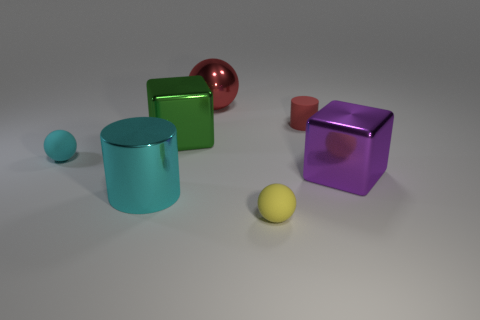Subtract all yellow matte balls. How many balls are left? 2 Add 1 metal cylinders. How many objects exist? 8 Subtract all purple blocks. How many blocks are left? 1 Subtract 1 cubes. How many cubes are left? 1 Subtract all spheres. How many objects are left? 4 Subtract all large cyan matte balls. Subtract all cyan cylinders. How many objects are left? 6 Add 2 red objects. How many red objects are left? 4 Add 1 rubber things. How many rubber things exist? 4 Subtract 0 cyan cubes. How many objects are left? 7 Subtract all gray balls. Subtract all yellow blocks. How many balls are left? 3 